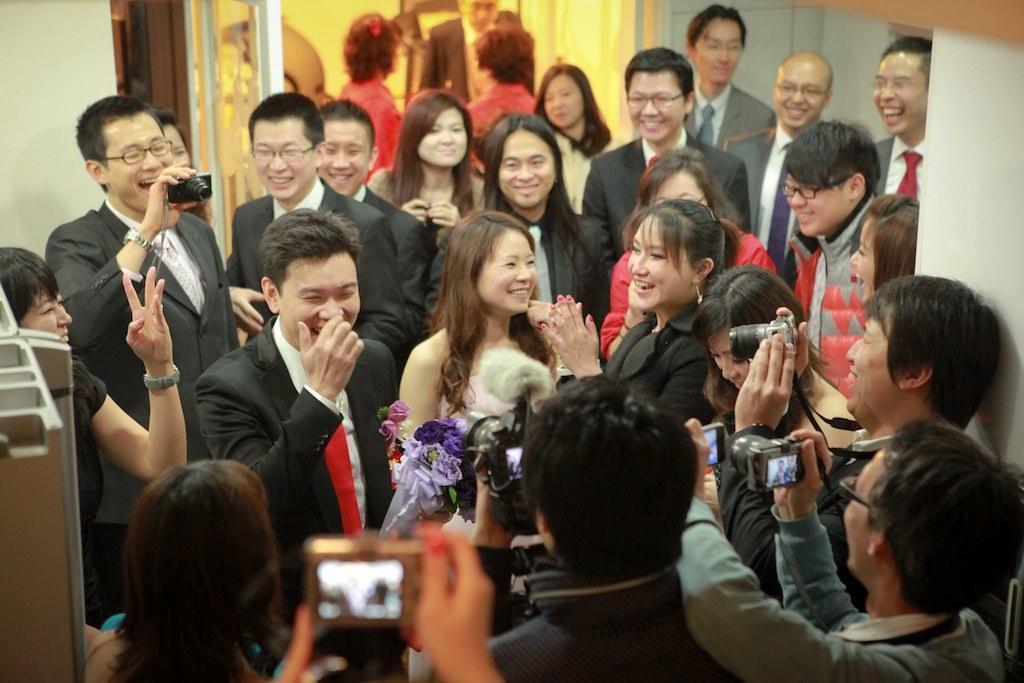In one or two sentences, can you explain what this image depicts? In this image, there are a few people. Among them, some people are holding cameras. We can also see the wall and some objects on the left. We can see some white colored objects. 